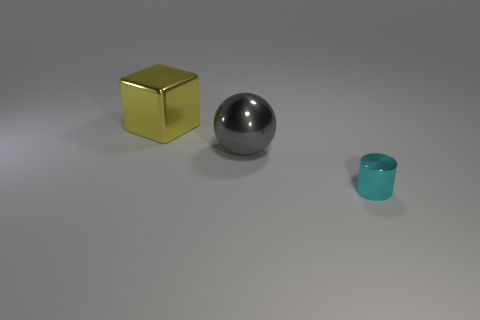Are there any other things that have the same size as the cylinder?
Your answer should be very brief. No. How many other big metallic blocks are the same color as the cube?
Your response must be concise. 0. Are there fewer cyan things behind the large metallic block than large yellow metallic blocks left of the tiny cylinder?
Ensure brevity in your answer.  Yes. Are there any yellow metallic objects that have the same size as the gray metallic sphere?
Provide a succinct answer. Yes. Do the big yellow thing and the object in front of the gray shiny sphere have the same shape?
Keep it short and to the point. No. There is a thing left of the large shiny ball; is its size the same as the shiny thing on the right side of the large gray thing?
Provide a short and direct response. No. How many other things are the same shape as the cyan thing?
Offer a very short reply. 0. What is the material of the big thing that is in front of the large thing that is left of the large gray metallic object?
Your answer should be compact. Metal. How many shiny things are either large spheres or purple spheres?
Your answer should be compact. 1. Are there any big yellow objects to the left of the large object that is in front of the large cube?
Keep it short and to the point. Yes. 